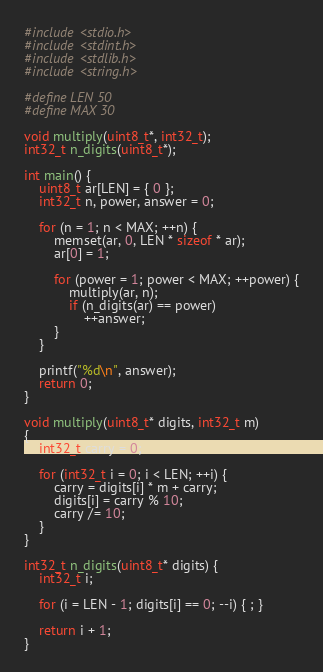Convert code to text. <code><loc_0><loc_0><loc_500><loc_500><_C_>#include <stdio.h>
#include <stdint.h>
#include <stdlib.h>
#include <string.h>

#define LEN 50
#define MAX 30

void multiply(uint8_t*, int32_t);
int32_t n_digits(uint8_t*);

int main() {
    uint8_t ar[LEN] = { 0 };
    int32_t n, power, answer = 0;

    for (n = 1; n < MAX; ++n) {
        memset(ar, 0, LEN * sizeof * ar);
        ar[0] = 1;

        for (power = 1; power < MAX; ++power) {
            multiply(ar, n);
            if (n_digits(ar) == power)
                ++answer;
        }
    }

    printf("%d\n", answer);
    return 0;
}

void multiply(uint8_t* digits, int32_t m)
{
    int32_t carry = 0;

    for (int32_t i = 0; i < LEN; ++i) {
        carry = digits[i] * m + carry;
        digits[i] = carry % 10;
        carry /= 10;
    }
}

int32_t n_digits(uint8_t* digits) {
    int32_t i;

    for (i = LEN - 1; digits[i] == 0; --i) { ; }

    return i + 1;
}
</code> 